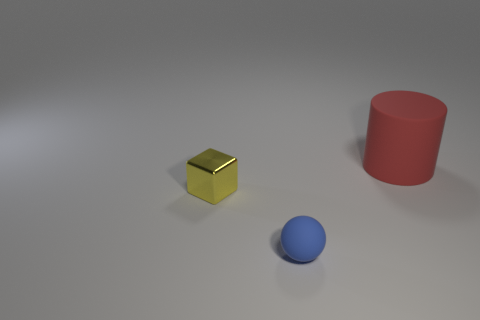What could be the purpose of these objects being placed together in this setup? This arrangement of distinctly colored and shaped objects could serve a variety of purposes. It may be part of a visual study in compositional aesthetics, where the contrasting shapes and colors create a balanced and pleasing image. Alternatively, it could be used in an educational setting to teach about geometric shapes, colors, or the principles of light and shadow in photography due to the soft lighting and subtle shadows present. 